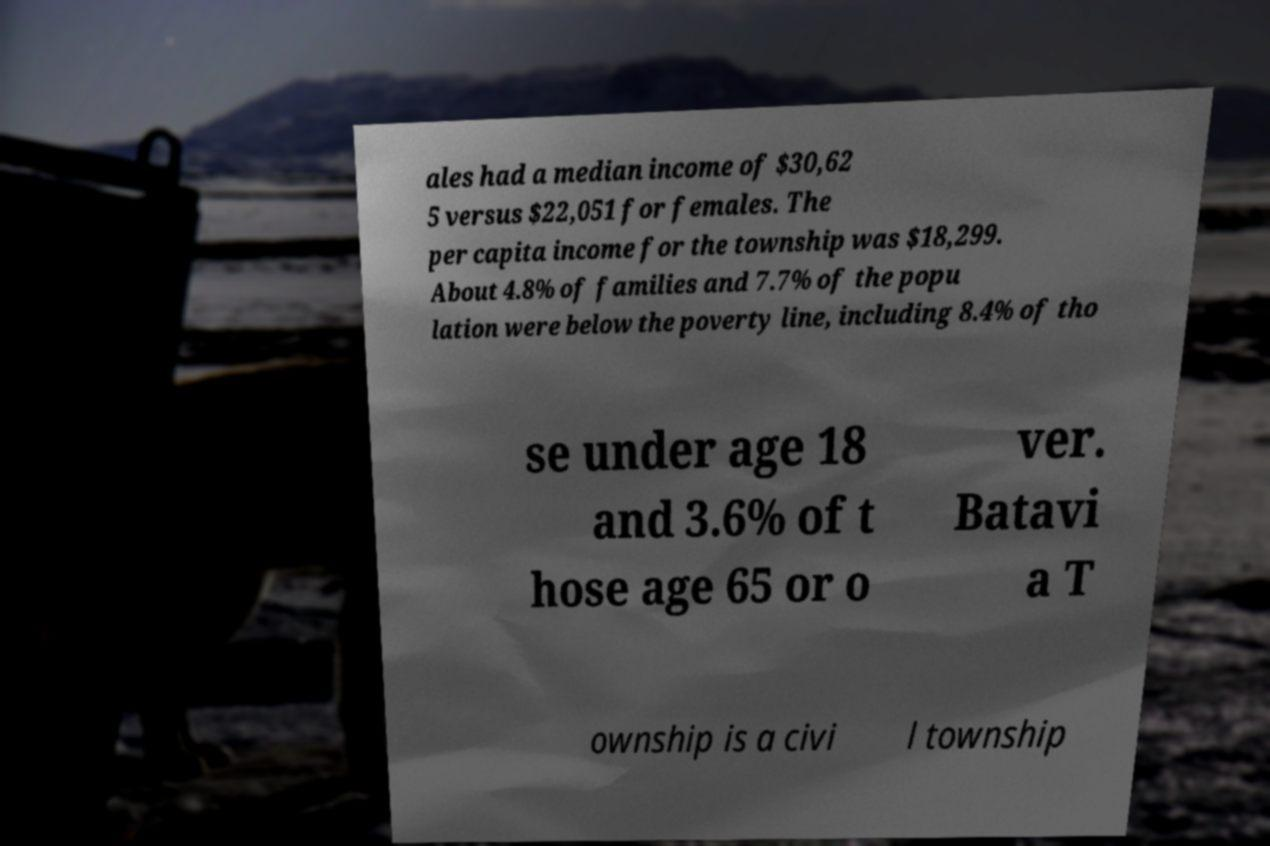Can you read and provide the text displayed in the image?This photo seems to have some interesting text. Can you extract and type it out for me? ales had a median income of $30,62 5 versus $22,051 for females. The per capita income for the township was $18,299. About 4.8% of families and 7.7% of the popu lation were below the poverty line, including 8.4% of tho se under age 18 and 3.6% of t hose age 65 or o ver. Batavi a T ownship is a civi l township 